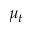<formula> <loc_0><loc_0><loc_500><loc_500>\mu _ { t }</formula> 